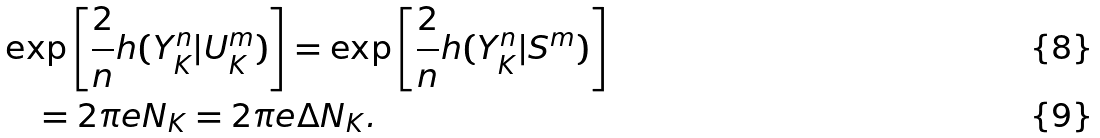Convert formula to latex. <formula><loc_0><loc_0><loc_500><loc_500>& \exp \left [ \frac { 2 } { n } h ( Y ^ { n } _ { K } | U ^ { m } _ { K } ) \right ] = \exp \left [ \frac { 2 } { n } h ( Y ^ { n } _ { K } | S ^ { m } ) \right ] \\ & \quad = 2 \pi e N _ { K } = 2 \pi e \Delta N _ { K } .</formula> 